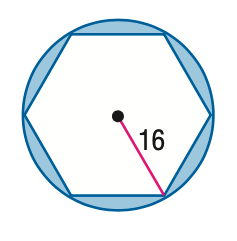Question: Find the area of the shaded region. Assume that the polygon is regular unless otherwise stated. Round to the nearest tenth.
Choices:
A. 139.1
B. 516.2
C. 721.1
D. 762.7
Answer with the letter. Answer: A 